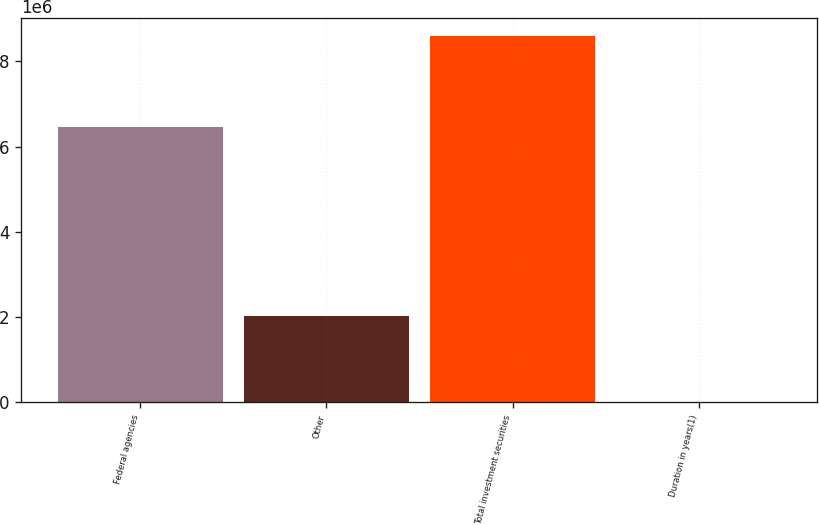Convert chart. <chart><loc_0><loc_0><loc_500><loc_500><bar_chart><fcel>Federal agencies<fcel>Other<fcel>Total investment securities<fcel>Duration in years(1)<nl><fcel>6.4675e+06<fcel>2.02126e+06<fcel>8.58791e+06<fcel>2.4<nl></chart> 